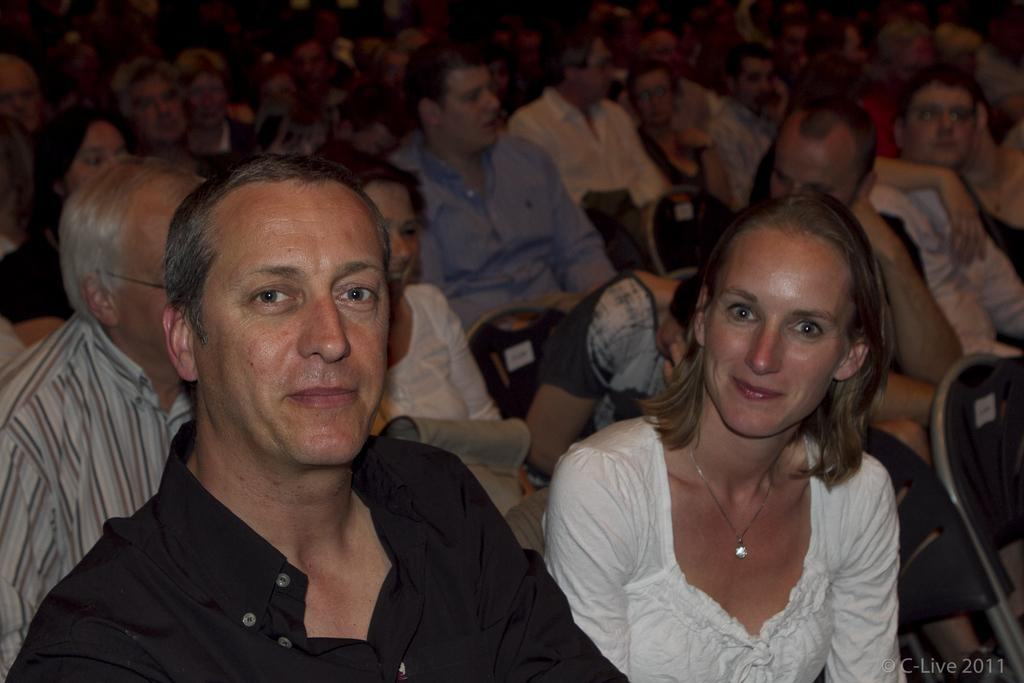What is the main subject of the image? The main subject of the image is a couple. What are the couple doing in the image? The couple is sitting on chairs in the image. Can you describe the arrangement of the chairs in the image? The chairs are arranged one beside the other in the image. What can be observed about the people in the background of the image? There are many people in the background of the image, and they are also sitting on chairs. What type of glue is being used by the couple in the image? There is no glue present in the image; the couple is simply sitting on chairs. 